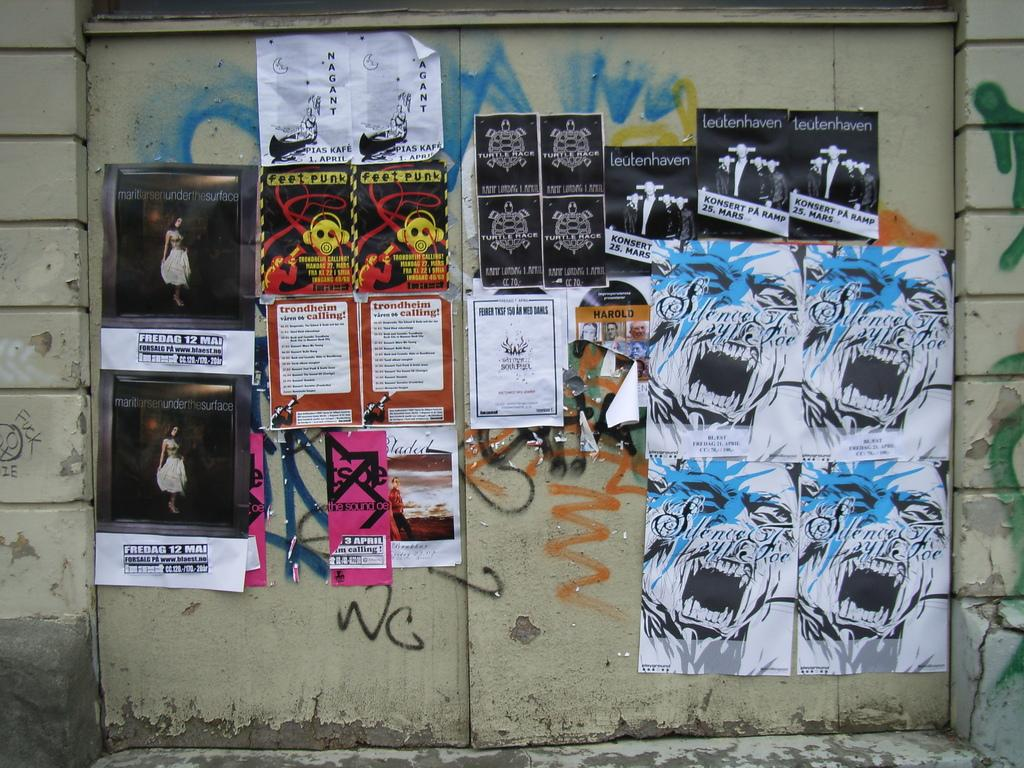What type of decorations can be seen in the image? There are posters in the image. What is attached to the door in the image? There are papers attached to the door in the image. What is the background of the image made of? There is a wall visible in the image. How many frogs are sitting on the posters in the image? There are no frogs present in the image. What type of zephyr can be seen blowing through the papers on the door? There is no zephyr present in the image, and the papers on the door are stationary. 